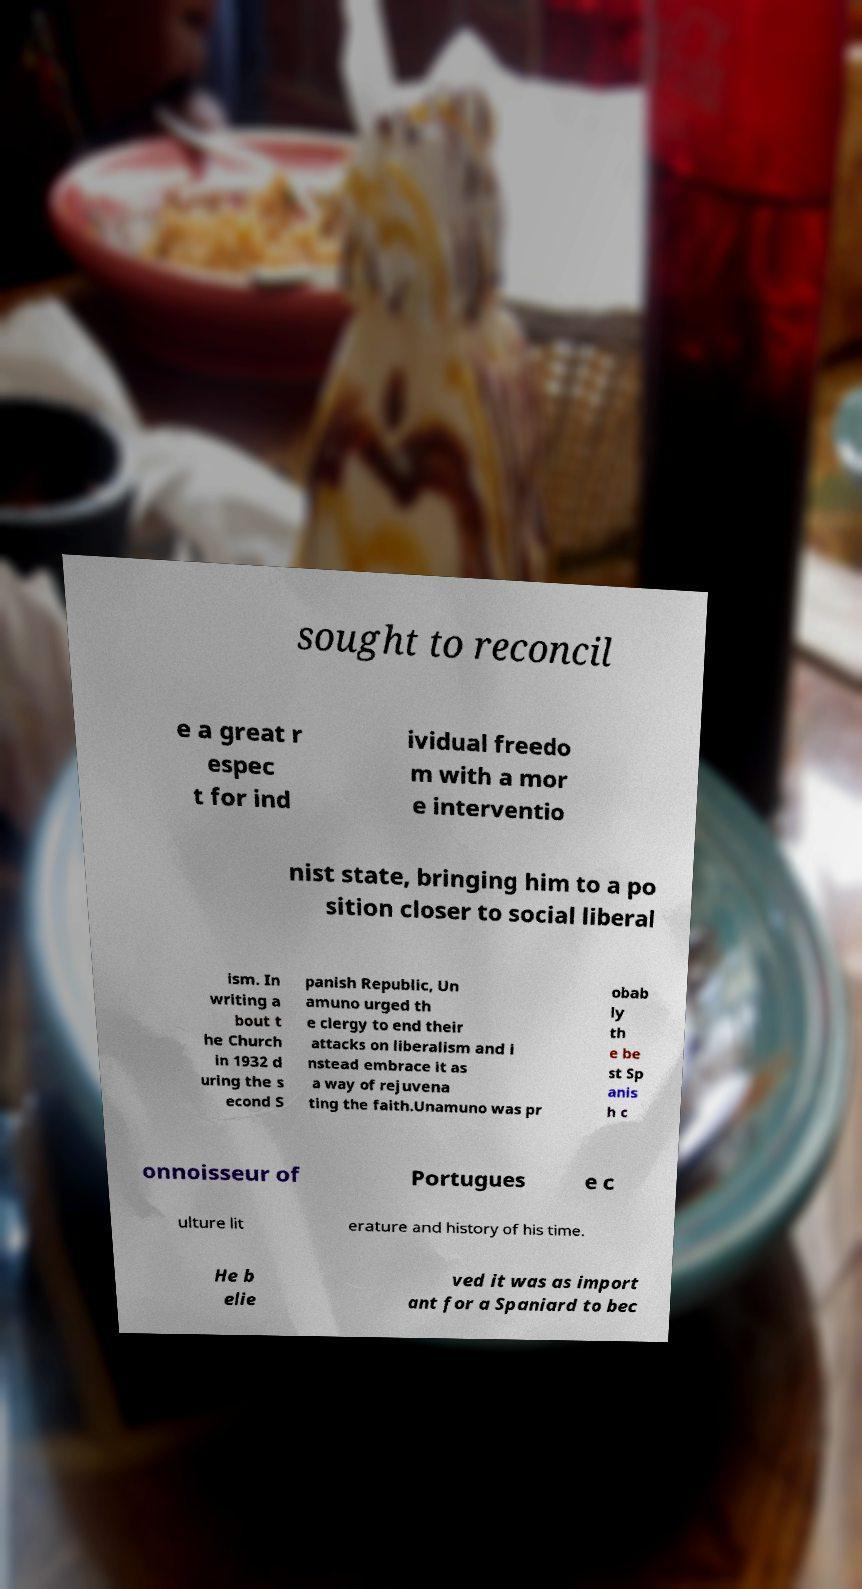Please identify and transcribe the text found in this image. sought to reconcil e a great r espec t for ind ividual freedo m with a mor e interventio nist state, bringing him to a po sition closer to social liberal ism. In writing a bout t he Church in 1932 d uring the s econd S panish Republic, Un amuno urged th e clergy to end their attacks on liberalism and i nstead embrace it as a way of rejuvena ting the faith.Unamuno was pr obab ly th e be st Sp anis h c onnoisseur of Portugues e c ulture lit erature and history of his time. He b elie ved it was as import ant for a Spaniard to bec 